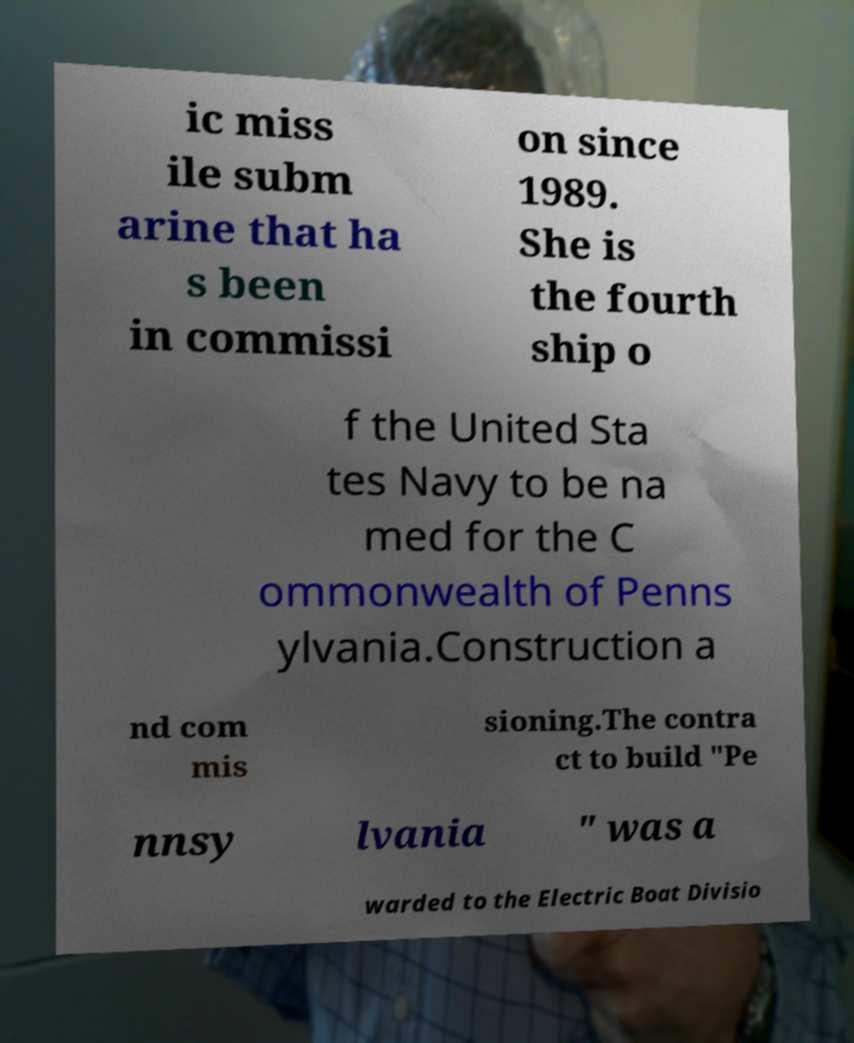What messages or text are displayed in this image? I need them in a readable, typed format. ic miss ile subm arine that ha s been in commissi on since 1989. She is the fourth ship o f the United Sta tes Navy to be na med for the C ommonwealth of Penns ylvania.Construction a nd com mis sioning.The contra ct to build "Pe nnsy lvania " was a warded to the Electric Boat Divisio 